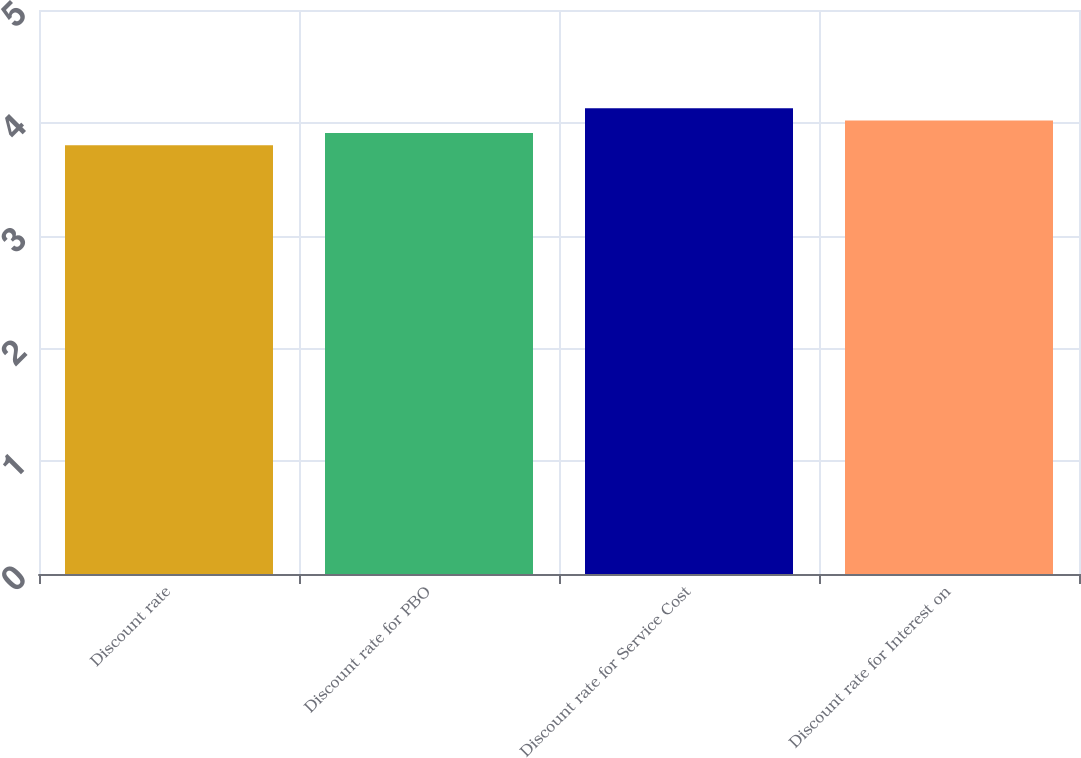<chart> <loc_0><loc_0><loc_500><loc_500><bar_chart><fcel>Discount rate<fcel>Discount rate for PBO<fcel>Discount rate for Service Cost<fcel>Discount rate for Interest on<nl><fcel>3.8<fcel>3.91<fcel>4.13<fcel>4.02<nl></chart> 